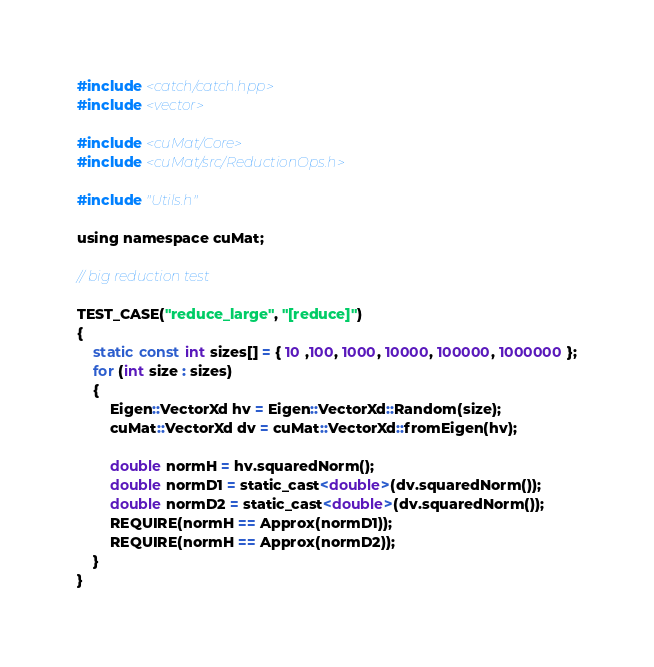<code> <loc_0><loc_0><loc_500><loc_500><_Cuda_>#include <catch/catch.hpp>
#include <vector>

#include <cuMat/Core>
#include <cuMat/src/ReductionOps.h>

#include "Utils.h"

using namespace cuMat;

// big reduction test

TEST_CASE("reduce_large", "[reduce]")
{
	static const int sizes[] = { 10 ,100, 1000, 10000, 100000, 1000000 };
	for (int size : sizes)
	{
		Eigen::VectorXd hv = Eigen::VectorXd::Random(size);
		cuMat::VectorXd dv = cuMat::VectorXd::fromEigen(hv);

		double normH = hv.squaredNorm();
		double normD1 = static_cast<double>(dv.squaredNorm());
		double normD2 = static_cast<double>(dv.squaredNorm());
		REQUIRE(normH == Approx(normD1));
		REQUIRE(normH == Approx(normD2));
	}
}</code> 